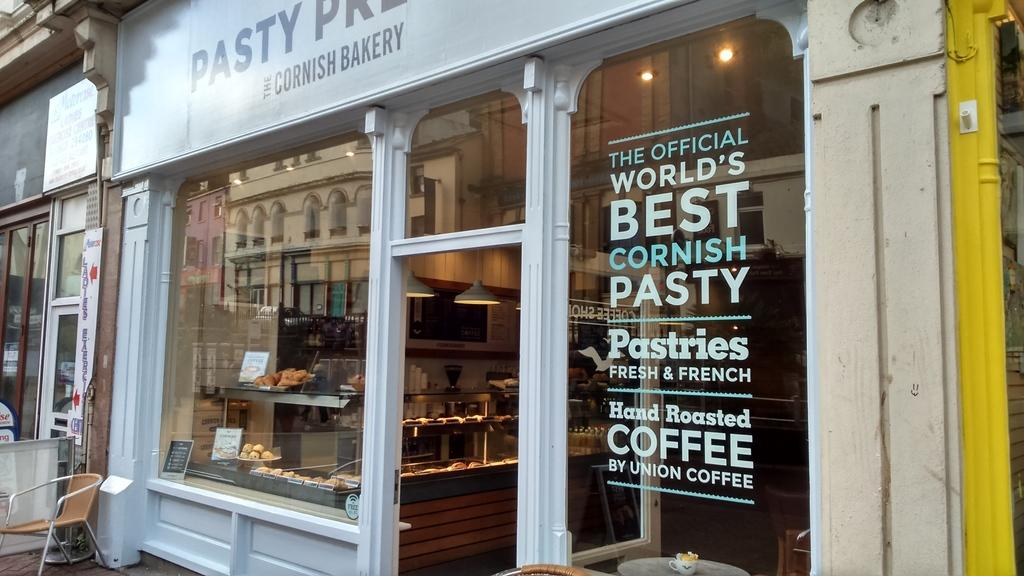Provide a one-sentence caption for the provided image. The exterior of a bakers shop with a window full of goodies on display and a sign saying the shop sells the the official worlds greatest cornish pasty. 